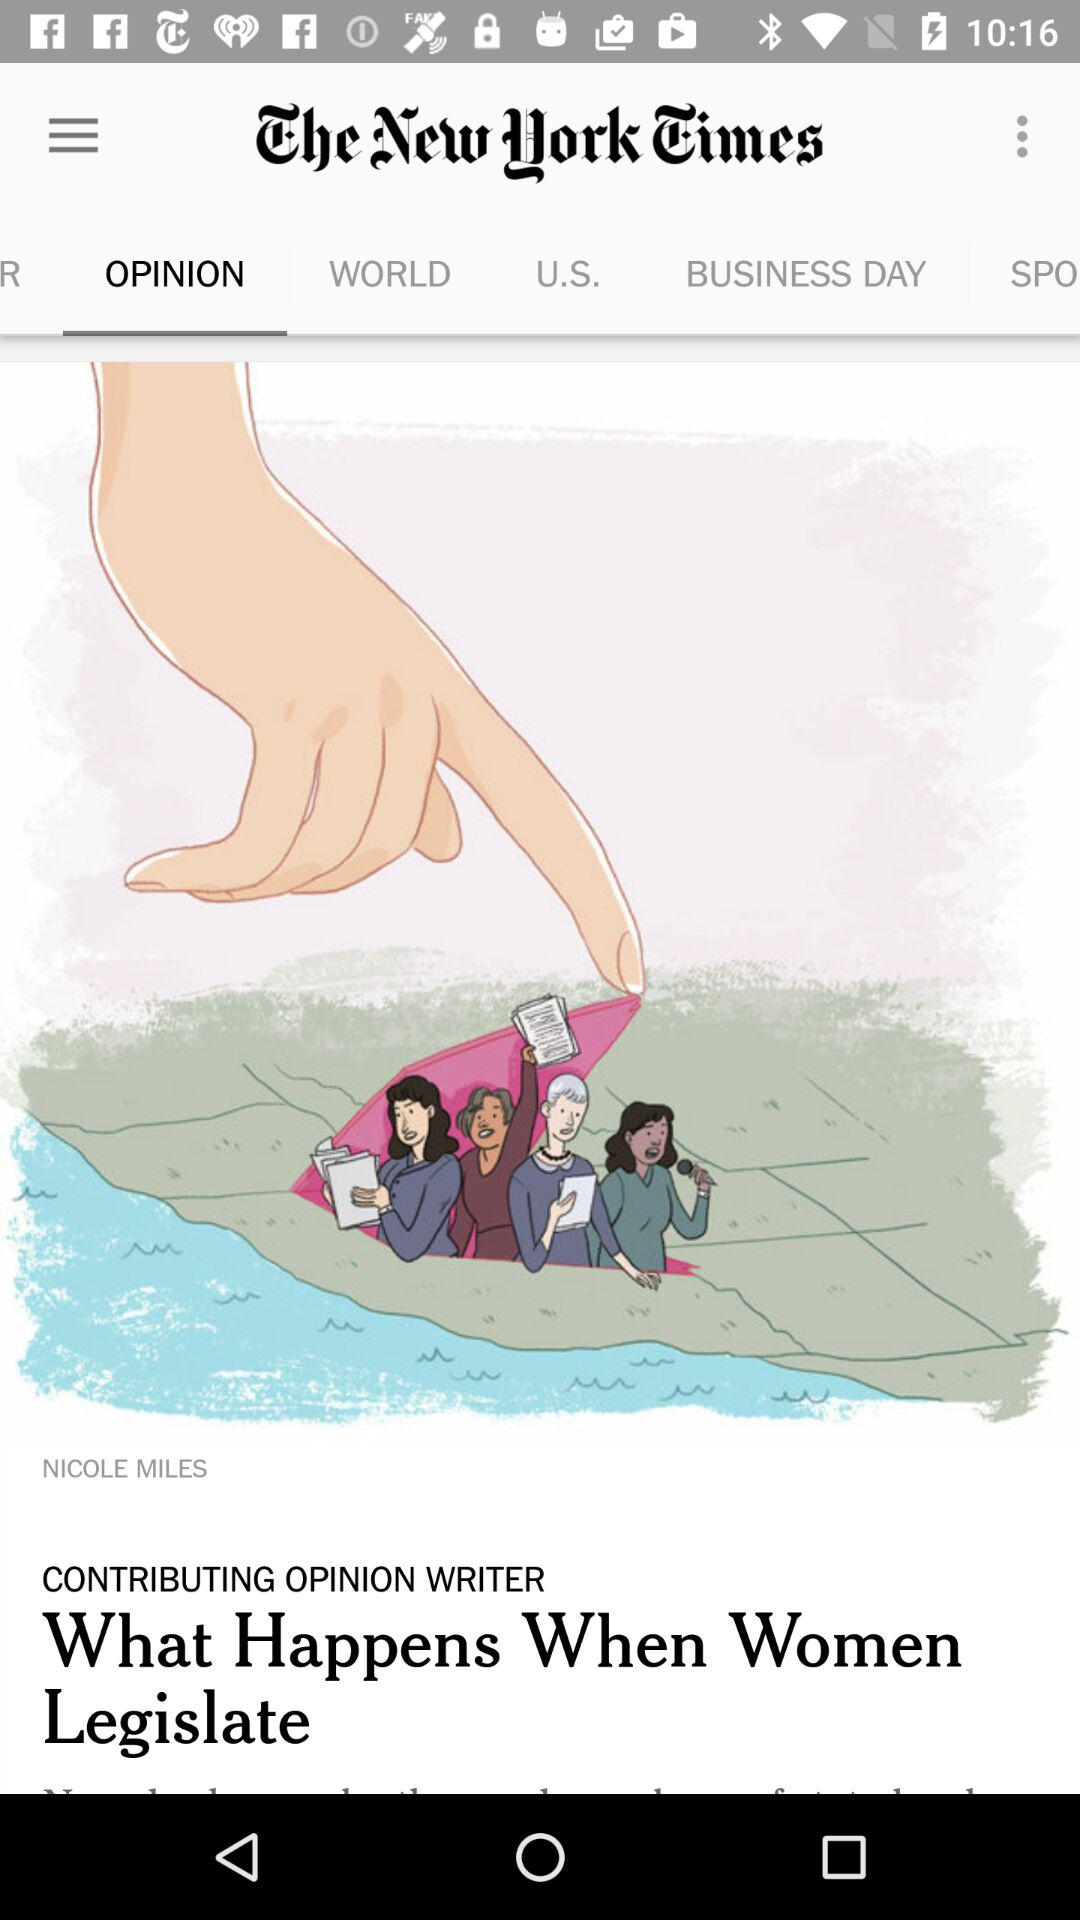What is the name of newspaper? The name of the newspaper is "The New York Times". 